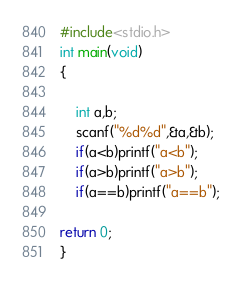Convert code to text. <code><loc_0><loc_0><loc_500><loc_500><_C_>#include<stdio.h>
int main(void)
{
	
	int a,b;
	scanf("%d%d",&a,&b);
	if(a<b)printf("a<b");
	if(a>b)printf("a>b");
	if(a==b)printf("a==b");
	
return 0;
}</code> 